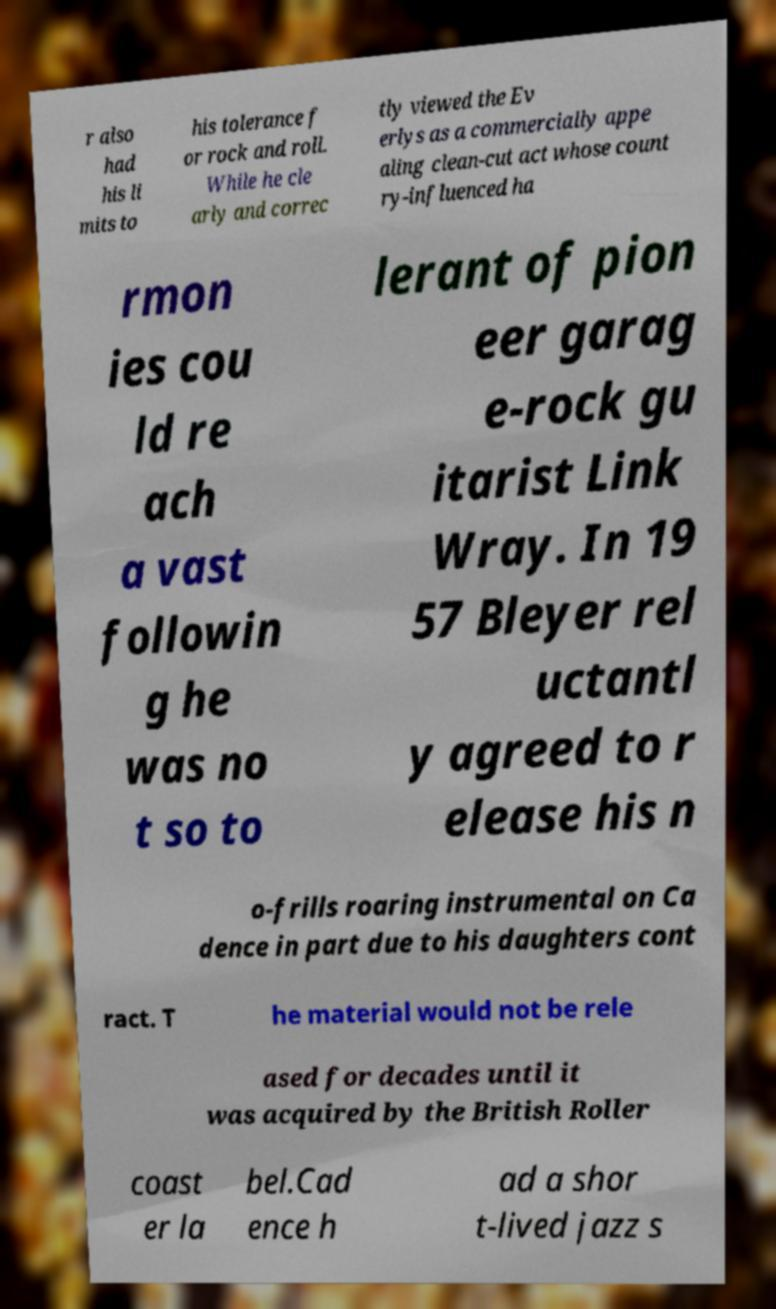Could you assist in decoding the text presented in this image and type it out clearly? r also had his li mits to his tolerance f or rock and roll. While he cle arly and correc tly viewed the Ev erlys as a commercially appe aling clean-cut act whose count ry-influenced ha rmon ies cou ld re ach a vast followin g he was no t so to lerant of pion eer garag e-rock gu itarist Link Wray. In 19 57 Bleyer rel uctantl y agreed to r elease his n o-frills roaring instrumental on Ca dence in part due to his daughters cont ract. T he material would not be rele ased for decades until it was acquired by the British Roller coast er la bel.Cad ence h ad a shor t-lived jazz s 